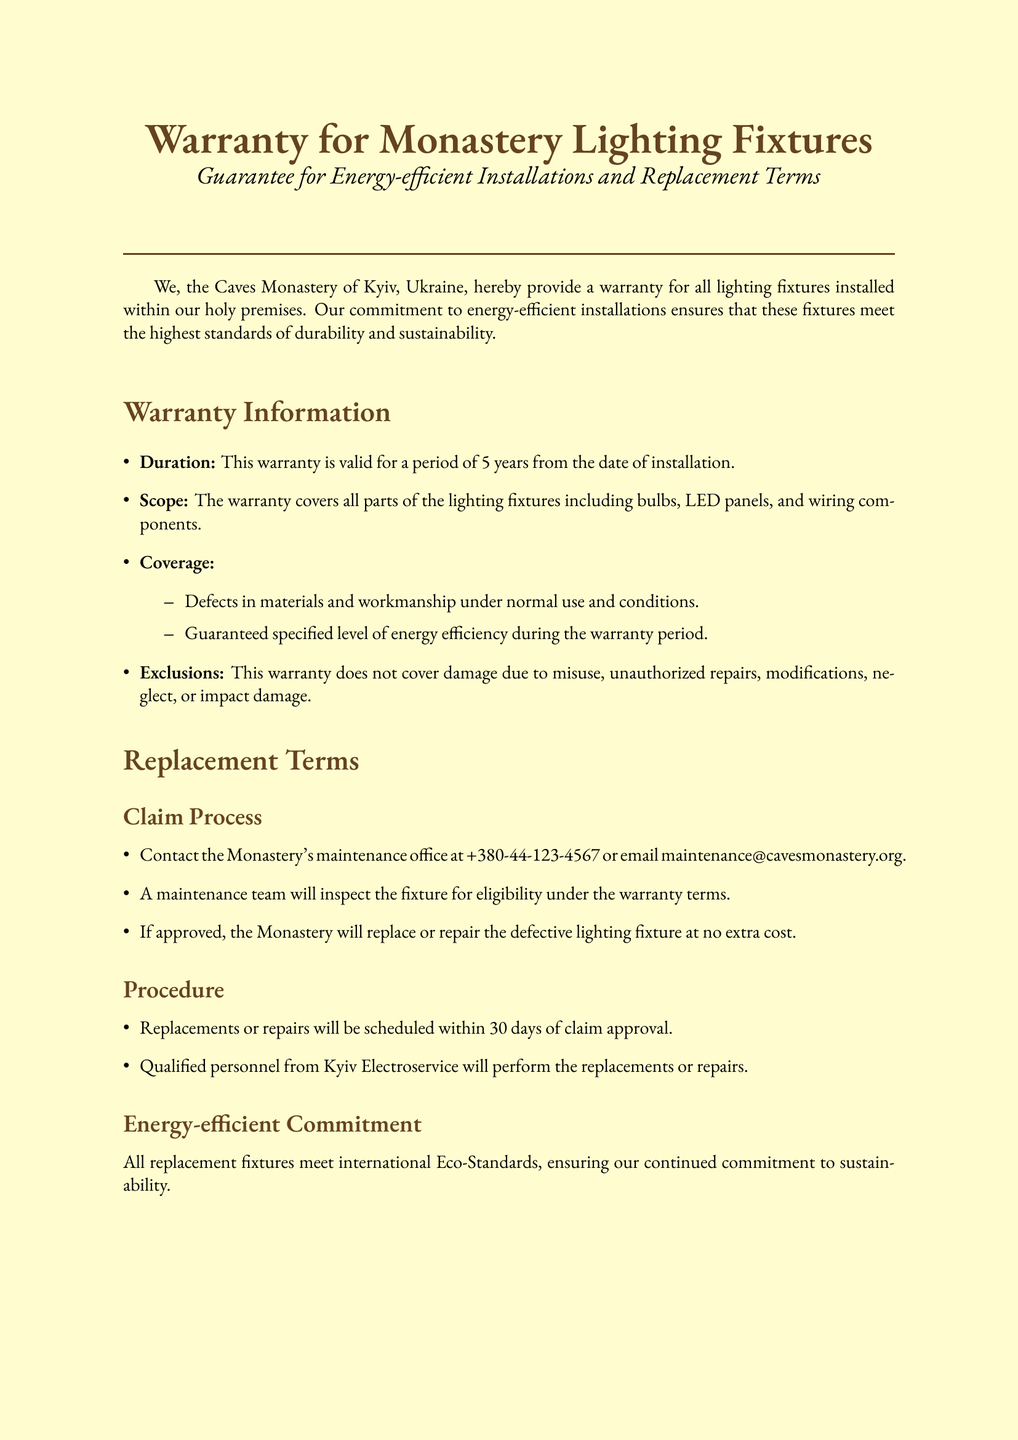What is the warranty duration for lighting fixtures? The warranty lasts for a specified time frame mentioned in the document.
Answer: 5 years What is covered under the warranty? The document outlines what aspects are included in the warranty coverage.
Answer: Defects in materials and workmanship What is excluded from the warranty? The document lists specific cases that are not covered by the warranty.
Answer: Misuse, unauthorized repairs, modifications What is the contact number for the maintenance office? The document provides a specific contact number for warranty claims.
Answer: +380-44-123-4567 How long will replacements be scheduled after claim approval? The document specifies the timeframe for scheduling replacements or repairs.
Answer: 30 days What is the role of Kyiv Electroservice in the warranty process? The document describes the entity responsible for performing the replacements or repairs.
Answer: Qualified personnel What is the potential energy savings mentioned? The document includes an estimate of energy consumption reduction related to lighting.
Answer: Up to 60 percent What types of installations does the warranty cover? The document clarifies the types of fixtures included in the warranty.
Answer: Lighting fixtures What do maintenance tips suggest? The document provides specific advice for maintaining the fixtures.
Answer: Regular dusting and avoiding harsh chemicals 